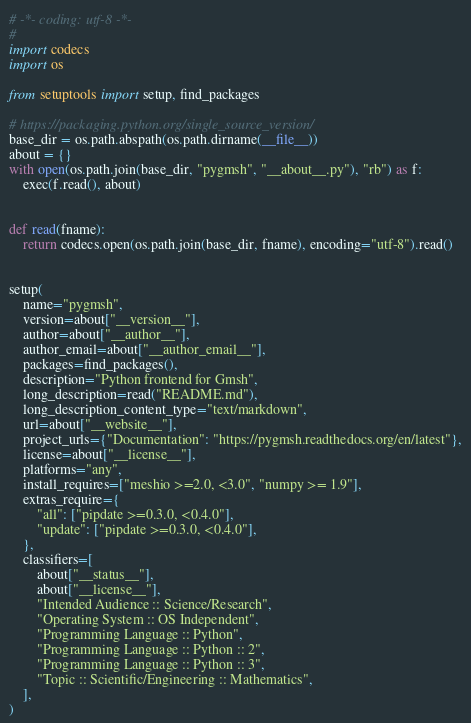<code> <loc_0><loc_0><loc_500><loc_500><_Python_># -*- coding: utf-8 -*-
#
import codecs
import os

from setuptools import setup, find_packages

# https://packaging.python.org/single_source_version/
base_dir = os.path.abspath(os.path.dirname(__file__))
about = {}
with open(os.path.join(base_dir, "pygmsh", "__about__.py"), "rb") as f:
    exec(f.read(), about)


def read(fname):
    return codecs.open(os.path.join(base_dir, fname), encoding="utf-8").read()


setup(
    name="pygmsh",
    version=about["__version__"],
    author=about["__author__"],
    author_email=about["__author_email__"],
    packages=find_packages(),
    description="Python frontend for Gmsh",
    long_description=read("README.md"),
    long_description_content_type="text/markdown",
    url=about["__website__"],
    project_urls={"Documentation": "https://pygmsh.readthedocs.org/en/latest"},
    license=about["__license__"],
    platforms="any",
    install_requires=["meshio >=2.0, <3.0", "numpy >= 1.9"],
    extras_require={
        "all": ["pipdate >=0.3.0, <0.4.0"],
        "update": ["pipdate >=0.3.0, <0.4.0"],
    },
    classifiers=[
        about["__status__"],
        about["__license__"],
        "Intended Audience :: Science/Research",
        "Operating System :: OS Independent",
        "Programming Language :: Python",
        "Programming Language :: Python :: 2",
        "Programming Language :: Python :: 3",
        "Topic :: Scientific/Engineering :: Mathematics",
    ],
)
</code> 